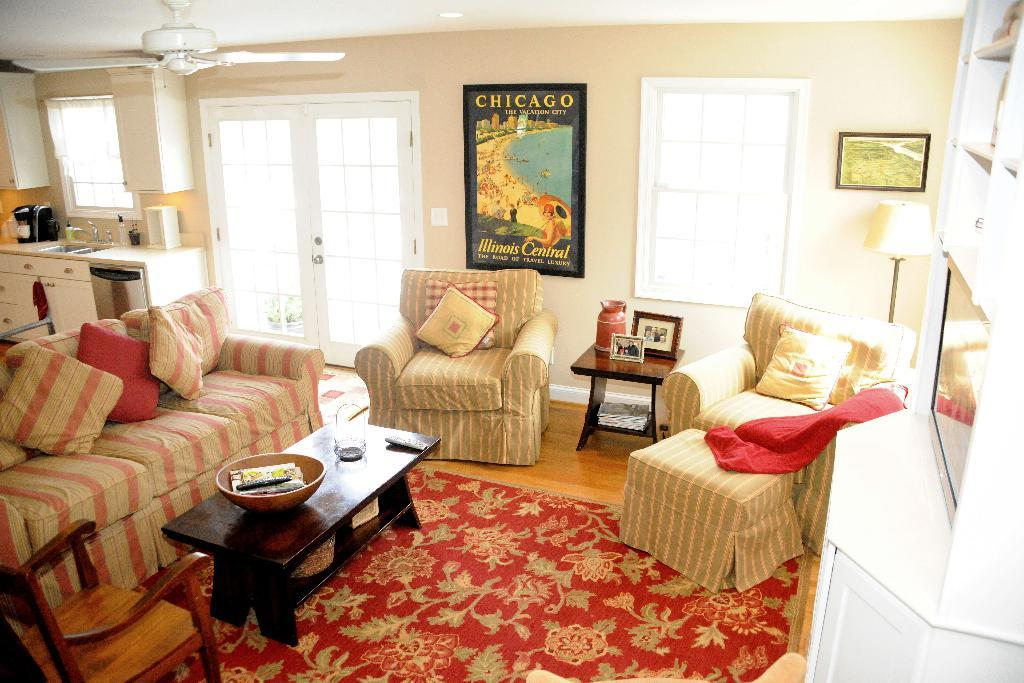What type of room is shown in the image? The image shows an inner view of a house. What piece of furniture is present for seating and sleeping? There is a sofa bed in the image. How many chairs are visible in the image? There are chairs in the image. What is used for placing objects and serving purposes? There is present in the image. A: There is a table in the image. What is hanging on the wall in the image? There is a photo frame on the wall in the image. What device is present for air circulation? There is a fan in the image. How many dogs are visible in the image? There are no dogs present in the image. What type of animal can be seen interacting with the photo frame on the wall? There are no animals visible in the image, and the photo frame is not interacting with any objects. What type of vegetable is being used as a decorative item on the table in the image? There are no vegetables present in the image, and the table is not used for decorative purposes. 